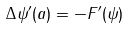Convert formula to latex. <formula><loc_0><loc_0><loc_500><loc_500>\Delta \psi ^ { \prime } ( a ) = - F ^ { \prime } ( \psi )</formula> 